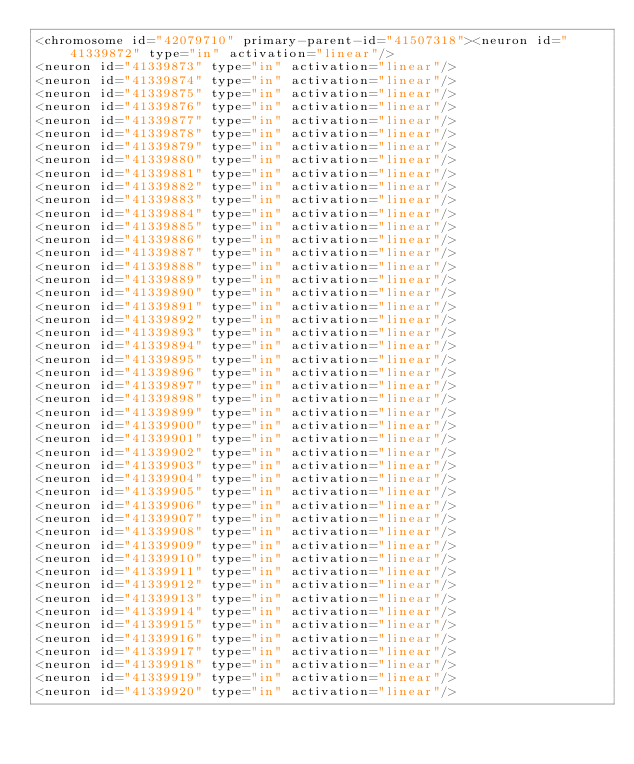<code> <loc_0><loc_0><loc_500><loc_500><_XML_><chromosome id="42079710" primary-parent-id="41507318"><neuron id="41339872" type="in" activation="linear"/>
<neuron id="41339873" type="in" activation="linear"/>
<neuron id="41339874" type="in" activation="linear"/>
<neuron id="41339875" type="in" activation="linear"/>
<neuron id="41339876" type="in" activation="linear"/>
<neuron id="41339877" type="in" activation="linear"/>
<neuron id="41339878" type="in" activation="linear"/>
<neuron id="41339879" type="in" activation="linear"/>
<neuron id="41339880" type="in" activation="linear"/>
<neuron id="41339881" type="in" activation="linear"/>
<neuron id="41339882" type="in" activation="linear"/>
<neuron id="41339883" type="in" activation="linear"/>
<neuron id="41339884" type="in" activation="linear"/>
<neuron id="41339885" type="in" activation="linear"/>
<neuron id="41339886" type="in" activation="linear"/>
<neuron id="41339887" type="in" activation="linear"/>
<neuron id="41339888" type="in" activation="linear"/>
<neuron id="41339889" type="in" activation="linear"/>
<neuron id="41339890" type="in" activation="linear"/>
<neuron id="41339891" type="in" activation="linear"/>
<neuron id="41339892" type="in" activation="linear"/>
<neuron id="41339893" type="in" activation="linear"/>
<neuron id="41339894" type="in" activation="linear"/>
<neuron id="41339895" type="in" activation="linear"/>
<neuron id="41339896" type="in" activation="linear"/>
<neuron id="41339897" type="in" activation="linear"/>
<neuron id="41339898" type="in" activation="linear"/>
<neuron id="41339899" type="in" activation="linear"/>
<neuron id="41339900" type="in" activation="linear"/>
<neuron id="41339901" type="in" activation="linear"/>
<neuron id="41339902" type="in" activation="linear"/>
<neuron id="41339903" type="in" activation="linear"/>
<neuron id="41339904" type="in" activation="linear"/>
<neuron id="41339905" type="in" activation="linear"/>
<neuron id="41339906" type="in" activation="linear"/>
<neuron id="41339907" type="in" activation="linear"/>
<neuron id="41339908" type="in" activation="linear"/>
<neuron id="41339909" type="in" activation="linear"/>
<neuron id="41339910" type="in" activation="linear"/>
<neuron id="41339911" type="in" activation="linear"/>
<neuron id="41339912" type="in" activation="linear"/>
<neuron id="41339913" type="in" activation="linear"/>
<neuron id="41339914" type="in" activation="linear"/>
<neuron id="41339915" type="in" activation="linear"/>
<neuron id="41339916" type="in" activation="linear"/>
<neuron id="41339917" type="in" activation="linear"/>
<neuron id="41339918" type="in" activation="linear"/>
<neuron id="41339919" type="in" activation="linear"/>
<neuron id="41339920" type="in" activation="linear"/></code> 